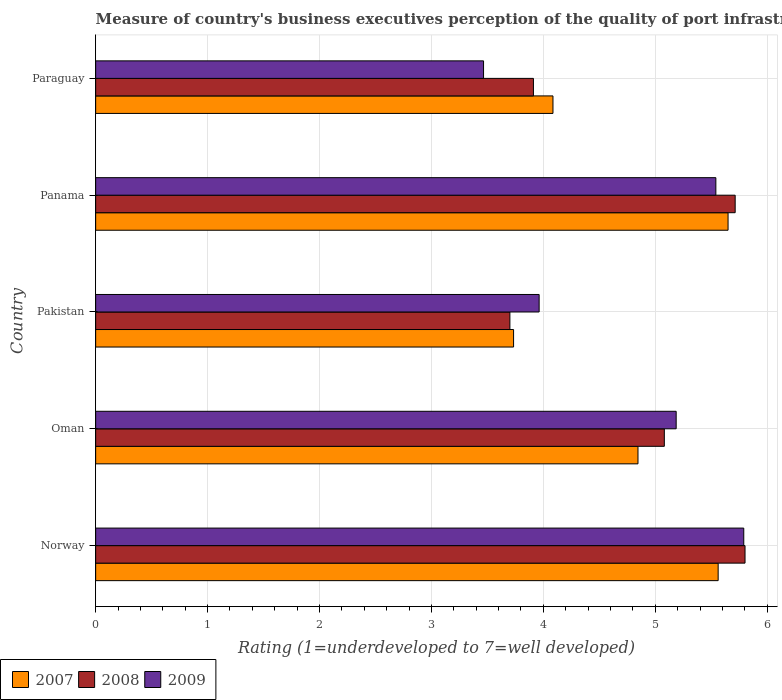How many different coloured bars are there?
Provide a short and direct response. 3. How many groups of bars are there?
Ensure brevity in your answer.  5. Are the number of bars on each tick of the Y-axis equal?
Give a very brief answer. Yes. How many bars are there on the 3rd tick from the top?
Your response must be concise. 3. What is the label of the 5th group of bars from the top?
Provide a short and direct response. Norway. In how many cases, is the number of bars for a given country not equal to the number of legend labels?
Your answer should be compact. 0. What is the ratings of the quality of port infrastructure in 2007 in Panama?
Provide a succinct answer. 5.65. Across all countries, what is the maximum ratings of the quality of port infrastructure in 2008?
Your answer should be very brief. 5.8. Across all countries, what is the minimum ratings of the quality of port infrastructure in 2009?
Offer a terse response. 3.47. In which country was the ratings of the quality of port infrastructure in 2007 maximum?
Provide a succinct answer. Panama. In which country was the ratings of the quality of port infrastructure in 2008 minimum?
Keep it short and to the point. Pakistan. What is the total ratings of the quality of port infrastructure in 2008 in the graph?
Your response must be concise. 24.21. What is the difference between the ratings of the quality of port infrastructure in 2008 in Pakistan and that in Panama?
Keep it short and to the point. -2.01. What is the difference between the ratings of the quality of port infrastructure in 2007 in Panama and the ratings of the quality of port infrastructure in 2009 in Paraguay?
Provide a short and direct response. 2.18. What is the average ratings of the quality of port infrastructure in 2009 per country?
Provide a short and direct response. 4.79. What is the difference between the ratings of the quality of port infrastructure in 2008 and ratings of the quality of port infrastructure in 2007 in Pakistan?
Give a very brief answer. -0.03. What is the ratio of the ratings of the quality of port infrastructure in 2008 in Oman to that in Panama?
Offer a terse response. 0.89. Is the ratings of the quality of port infrastructure in 2008 in Norway less than that in Oman?
Your response must be concise. No. What is the difference between the highest and the second highest ratings of the quality of port infrastructure in 2009?
Make the answer very short. 0.25. What is the difference between the highest and the lowest ratings of the quality of port infrastructure in 2009?
Provide a short and direct response. 2.32. How many bars are there?
Offer a terse response. 15. What is the difference between two consecutive major ticks on the X-axis?
Give a very brief answer. 1. Are the values on the major ticks of X-axis written in scientific E-notation?
Your response must be concise. No. Does the graph contain grids?
Offer a very short reply. Yes. How many legend labels are there?
Ensure brevity in your answer.  3. How are the legend labels stacked?
Provide a short and direct response. Horizontal. What is the title of the graph?
Your answer should be compact. Measure of country's business executives perception of the quality of port infrastructure. Does "1978" appear as one of the legend labels in the graph?
Ensure brevity in your answer.  No. What is the label or title of the X-axis?
Offer a terse response. Rating (1=underdeveloped to 7=well developed). What is the Rating (1=underdeveloped to 7=well developed) in 2007 in Norway?
Give a very brief answer. 5.56. What is the Rating (1=underdeveloped to 7=well developed) in 2008 in Norway?
Provide a succinct answer. 5.8. What is the Rating (1=underdeveloped to 7=well developed) in 2009 in Norway?
Give a very brief answer. 5.79. What is the Rating (1=underdeveloped to 7=well developed) of 2007 in Oman?
Ensure brevity in your answer.  4.85. What is the Rating (1=underdeveloped to 7=well developed) of 2008 in Oman?
Offer a terse response. 5.08. What is the Rating (1=underdeveloped to 7=well developed) in 2009 in Oman?
Ensure brevity in your answer.  5.19. What is the Rating (1=underdeveloped to 7=well developed) of 2007 in Pakistan?
Your response must be concise. 3.73. What is the Rating (1=underdeveloped to 7=well developed) in 2008 in Pakistan?
Offer a terse response. 3.7. What is the Rating (1=underdeveloped to 7=well developed) in 2009 in Pakistan?
Provide a succinct answer. 3.96. What is the Rating (1=underdeveloped to 7=well developed) in 2007 in Panama?
Offer a very short reply. 5.65. What is the Rating (1=underdeveloped to 7=well developed) in 2008 in Panama?
Make the answer very short. 5.71. What is the Rating (1=underdeveloped to 7=well developed) in 2009 in Panama?
Provide a succinct answer. 5.54. What is the Rating (1=underdeveloped to 7=well developed) of 2007 in Paraguay?
Provide a succinct answer. 4.09. What is the Rating (1=underdeveloped to 7=well developed) of 2008 in Paraguay?
Ensure brevity in your answer.  3.91. What is the Rating (1=underdeveloped to 7=well developed) of 2009 in Paraguay?
Offer a terse response. 3.47. Across all countries, what is the maximum Rating (1=underdeveloped to 7=well developed) in 2007?
Provide a succinct answer. 5.65. Across all countries, what is the maximum Rating (1=underdeveloped to 7=well developed) in 2008?
Make the answer very short. 5.8. Across all countries, what is the maximum Rating (1=underdeveloped to 7=well developed) in 2009?
Your answer should be compact. 5.79. Across all countries, what is the minimum Rating (1=underdeveloped to 7=well developed) of 2007?
Your answer should be very brief. 3.73. Across all countries, what is the minimum Rating (1=underdeveloped to 7=well developed) in 2008?
Make the answer very short. 3.7. Across all countries, what is the minimum Rating (1=underdeveloped to 7=well developed) in 2009?
Offer a very short reply. 3.47. What is the total Rating (1=underdeveloped to 7=well developed) of 2007 in the graph?
Give a very brief answer. 23.88. What is the total Rating (1=underdeveloped to 7=well developed) of 2008 in the graph?
Make the answer very short. 24.21. What is the total Rating (1=underdeveloped to 7=well developed) in 2009 in the graph?
Offer a terse response. 23.95. What is the difference between the Rating (1=underdeveloped to 7=well developed) of 2007 in Norway and that in Oman?
Keep it short and to the point. 0.72. What is the difference between the Rating (1=underdeveloped to 7=well developed) in 2008 in Norway and that in Oman?
Keep it short and to the point. 0.72. What is the difference between the Rating (1=underdeveloped to 7=well developed) of 2009 in Norway and that in Oman?
Keep it short and to the point. 0.6. What is the difference between the Rating (1=underdeveloped to 7=well developed) of 2007 in Norway and that in Pakistan?
Offer a very short reply. 1.83. What is the difference between the Rating (1=underdeveloped to 7=well developed) in 2008 in Norway and that in Pakistan?
Offer a very short reply. 2.1. What is the difference between the Rating (1=underdeveloped to 7=well developed) in 2009 in Norway and that in Pakistan?
Offer a terse response. 1.83. What is the difference between the Rating (1=underdeveloped to 7=well developed) in 2007 in Norway and that in Panama?
Ensure brevity in your answer.  -0.09. What is the difference between the Rating (1=underdeveloped to 7=well developed) in 2008 in Norway and that in Panama?
Your response must be concise. 0.09. What is the difference between the Rating (1=underdeveloped to 7=well developed) in 2009 in Norway and that in Panama?
Your response must be concise. 0.25. What is the difference between the Rating (1=underdeveloped to 7=well developed) of 2007 in Norway and that in Paraguay?
Your response must be concise. 1.48. What is the difference between the Rating (1=underdeveloped to 7=well developed) in 2008 in Norway and that in Paraguay?
Your response must be concise. 1.89. What is the difference between the Rating (1=underdeveloped to 7=well developed) in 2009 in Norway and that in Paraguay?
Offer a very short reply. 2.32. What is the difference between the Rating (1=underdeveloped to 7=well developed) in 2007 in Oman and that in Pakistan?
Your response must be concise. 1.11. What is the difference between the Rating (1=underdeveloped to 7=well developed) in 2008 in Oman and that in Pakistan?
Offer a terse response. 1.38. What is the difference between the Rating (1=underdeveloped to 7=well developed) of 2009 in Oman and that in Pakistan?
Your answer should be very brief. 1.22. What is the difference between the Rating (1=underdeveloped to 7=well developed) in 2007 in Oman and that in Panama?
Your response must be concise. -0.8. What is the difference between the Rating (1=underdeveloped to 7=well developed) in 2008 in Oman and that in Panama?
Provide a short and direct response. -0.63. What is the difference between the Rating (1=underdeveloped to 7=well developed) of 2009 in Oman and that in Panama?
Give a very brief answer. -0.35. What is the difference between the Rating (1=underdeveloped to 7=well developed) of 2007 in Oman and that in Paraguay?
Provide a succinct answer. 0.76. What is the difference between the Rating (1=underdeveloped to 7=well developed) in 2008 in Oman and that in Paraguay?
Ensure brevity in your answer.  1.17. What is the difference between the Rating (1=underdeveloped to 7=well developed) in 2009 in Oman and that in Paraguay?
Your answer should be compact. 1.72. What is the difference between the Rating (1=underdeveloped to 7=well developed) in 2007 in Pakistan and that in Panama?
Your answer should be very brief. -1.92. What is the difference between the Rating (1=underdeveloped to 7=well developed) of 2008 in Pakistan and that in Panama?
Provide a succinct answer. -2.01. What is the difference between the Rating (1=underdeveloped to 7=well developed) in 2009 in Pakistan and that in Panama?
Provide a succinct answer. -1.58. What is the difference between the Rating (1=underdeveloped to 7=well developed) in 2007 in Pakistan and that in Paraguay?
Your answer should be compact. -0.35. What is the difference between the Rating (1=underdeveloped to 7=well developed) in 2008 in Pakistan and that in Paraguay?
Provide a succinct answer. -0.21. What is the difference between the Rating (1=underdeveloped to 7=well developed) of 2009 in Pakistan and that in Paraguay?
Ensure brevity in your answer.  0.5. What is the difference between the Rating (1=underdeveloped to 7=well developed) of 2007 in Panama and that in Paraguay?
Ensure brevity in your answer.  1.56. What is the difference between the Rating (1=underdeveloped to 7=well developed) of 2008 in Panama and that in Paraguay?
Your answer should be compact. 1.8. What is the difference between the Rating (1=underdeveloped to 7=well developed) in 2009 in Panama and that in Paraguay?
Offer a very short reply. 2.08. What is the difference between the Rating (1=underdeveloped to 7=well developed) of 2007 in Norway and the Rating (1=underdeveloped to 7=well developed) of 2008 in Oman?
Provide a short and direct response. 0.48. What is the difference between the Rating (1=underdeveloped to 7=well developed) of 2007 in Norway and the Rating (1=underdeveloped to 7=well developed) of 2009 in Oman?
Provide a short and direct response. 0.38. What is the difference between the Rating (1=underdeveloped to 7=well developed) in 2008 in Norway and the Rating (1=underdeveloped to 7=well developed) in 2009 in Oman?
Offer a terse response. 0.62. What is the difference between the Rating (1=underdeveloped to 7=well developed) of 2007 in Norway and the Rating (1=underdeveloped to 7=well developed) of 2008 in Pakistan?
Your answer should be compact. 1.86. What is the difference between the Rating (1=underdeveloped to 7=well developed) of 2007 in Norway and the Rating (1=underdeveloped to 7=well developed) of 2009 in Pakistan?
Give a very brief answer. 1.6. What is the difference between the Rating (1=underdeveloped to 7=well developed) of 2008 in Norway and the Rating (1=underdeveloped to 7=well developed) of 2009 in Pakistan?
Offer a very short reply. 1.84. What is the difference between the Rating (1=underdeveloped to 7=well developed) in 2007 in Norway and the Rating (1=underdeveloped to 7=well developed) in 2008 in Panama?
Offer a terse response. -0.15. What is the difference between the Rating (1=underdeveloped to 7=well developed) of 2007 in Norway and the Rating (1=underdeveloped to 7=well developed) of 2009 in Panama?
Keep it short and to the point. 0.02. What is the difference between the Rating (1=underdeveloped to 7=well developed) of 2008 in Norway and the Rating (1=underdeveloped to 7=well developed) of 2009 in Panama?
Offer a terse response. 0.26. What is the difference between the Rating (1=underdeveloped to 7=well developed) in 2007 in Norway and the Rating (1=underdeveloped to 7=well developed) in 2008 in Paraguay?
Provide a succinct answer. 1.65. What is the difference between the Rating (1=underdeveloped to 7=well developed) of 2007 in Norway and the Rating (1=underdeveloped to 7=well developed) of 2009 in Paraguay?
Offer a very short reply. 2.1. What is the difference between the Rating (1=underdeveloped to 7=well developed) of 2008 in Norway and the Rating (1=underdeveloped to 7=well developed) of 2009 in Paraguay?
Provide a short and direct response. 2.34. What is the difference between the Rating (1=underdeveloped to 7=well developed) in 2007 in Oman and the Rating (1=underdeveloped to 7=well developed) in 2008 in Pakistan?
Provide a short and direct response. 1.14. What is the difference between the Rating (1=underdeveloped to 7=well developed) of 2007 in Oman and the Rating (1=underdeveloped to 7=well developed) of 2009 in Pakistan?
Your answer should be very brief. 0.88. What is the difference between the Rating (1=underdeveloped to 7=well developed) of 2008 in Oman and the Rating (1=underdeveloped to 7=well developed) of 2009 in Pakistan?
Ensure brevity in your answer.  1.12. What is the difference between the Rating (1=underdeveloped to 7=well developed) of 2007 in Oman and the Rating (1=underdeveloped to 7=well developed) of 2008 in Panama?
Offer a very short reply. -0.87. What is the difference between the Rating (1=underdeveloped to 7=well developed) of 2007 in Oman and the Rating (1=underdeveloped to 7=well developed) of 2009 in Panama?
Your answer should be very brief. -0.7. What is the difference between the Rating (1=underdeveloped to 7=well developed) in 2008 in Oman and the Rating (1=underdeveloped to 7=well developed) in 2009 in Panama?
Your answer should be very brief. -0.46. What is the difference between the Rating (1=underdeveloped to 7=well developed) of 2007 in Oman and the Rating (1=underdeveloped to 7=well developed) of 2008 in Paraguay?
Keep it short and to the point. 0.93. What is the difference between the Rating (1=underdeveloped to 7=well developed) of 2007 in Oman and the Rating (1=underdeveloped to 7=well developed) of 2009 in Paraguay?
Your answer should be very brief. 1.38. What is the difference between the Rating (1=underdeveloped to 7=well developed) in 2008 in Oman and the Rating (1=underdeveloped to 7=well developed) in 2009 in Paraguay?
Your answer should be compact. 1.62. What is the difference between the Rating (1=underdeveloped to 7=well developed) in 2007 in Pakistan and the Rating (1=underdeveloped to 7=well developed) in 2008 in Panama?
Ensure brevity in your answer.  -1.98. What is the difference between the Rating (1=underdeveloped to 7=well developed) in 2007 in Pakistan and the Rating (1=underdeveloped to 7=well developed) in 2009 in Panama?
Make the answer very short. -1.81. What is the difference between the Rating (1=underdeveloped to 7=well developed) in 2008 in Pakistan and the Rating (1=underdeveloped to 7=well developed) in 2009 in Panama?
Offer a terse response. -1.84. What is the difference between the Rating (1=underdeveloped to 7=well developed) of 2007 in Pakistan and the Rating (1=underdeveloped to 7=well developed) of 2008 in Paraguay?
Your answer should be compact. -0.18. What is the difference between the Rating (1=underdeveloped to 7=well developed) of 2007 in Pakistan and the Rating (1=underdeveloped to 7=well developed) of 2009 in Paraguay?
Make the answer very short. 0.27. What is the difference between the Rating (1=underdeveloped to 7=well developed) of 2008 in Pakistan and the Rating (1=underdeveloped to 7=well developed) of 2009 in Paraguay?
Your answer should be very brief. 0.24. What is the difference between the Rating (1=underdeveloped to 7=well developed) of 2007 in Panama and the Rating (1=underdeveloped to 7=well developed) of 2008 in Paraguay?
Provide a short and direct response. 1.74. What is the difference between the Rating (1=underdeveloped to 7=well developed) in 2007 in Panama and the Rating (1=underdeveloped to 7=well developed) in 2009 in Paraguay?
Provide a short and direct response. 2.18. What is the difference between the Rating (1=underdeveloped to 7=well developed) of 2008 in Panama and the Rating (1=underdeveloped to 7=well developed) of 2009 in Paraguay?
Your answer should be very brief. 2.25. What is the average Rating (1=underdeveloped to 7=well developed) in 2007 per country?
Provide a succinct answer. 4.78. What is the average Rating (1=underdeveloped to 7=well developed) in 2008 per country?
Your answer should be compact. 4.84. What is the average Rating (1=underdeveloped to 7=well developed) of 2009 per country?
Your response must be concise. 4.79. What is the difference between the Rating (1=underdeveloped to 7=well developed) of 2007 and Rating (1=underdeveloped to 7=well developed) of 2008 in Norway?
Your answer should be compact. -0.24. What is the difference between the Rating (1=underdeveloped to 7=well developed) in 2007 and Rating (1=underdeveloped to 7=well developed) in 2009 in Norway?
Offer a terse response. -0.23. What is the difference between the Rating (1=underdeveloped to 7=well developed) of 2008 and Rating (1=underdeveloped to 7=well developed) of 2009 in Norway?
Your answer should be very brief. 0.01. What is the difference between the Rating (1=underdeveloped to 7=well developed) of 2007 and Rating (1=underdeveloped to 7=well developed) of 2008 in Oman?
Provide a short and direct response. -0.24. What is the difference between the Rating (1=underdeveloped to 7=well developed) in 2007 and Rating (1=underdeveloped to 7=well developed) in 2009 in Oman?
Give a very brief answer. -0.34. What is the difference between the Rating (1=underdeveloped to 7=well developed) of 2008 and Rating (1=underdeveloped to 7=well developed) of 2009 in Oman?
Provide a succinct answer. -0.11. What is the difference between the Rating (1=underdeveloped to 7=well developed) of 2007 and Rating (1=underdeveloped to 7=well developed) of 2008 in Pakistan?
Make the answer very short. 0.03. What is the difference between the Rating (1=underdeveloped to 7=well developed) in 2007 and Rating (1=underdeveloped to 7=well developed) in 2009 in Pakistan?
Your answer should be compact. -0.23. What is the difference between the Rating (1=underdeveloped to 7=well developed) in 2008 and Rating (1=underdeveloped to 7=well developed) in 2009 in Pakistan?
Give a very brief answer. -0.26. What is the difference between the Rating (1=underdeveloped to 7=well developed) in 2007 and Rating (1=underdeveloped to 7=well developed) in 2008 in Panama?
Your answer should be compact. -0.06. What is the difference between the Rating (1=underdeveloped to 7=well developed) of 2007 and Rating (1=underdeveloped to 7=well developed) of 2009 in Panama?
Make the answer very short. 0.11. What is the difference between the Rating (1=underdeveloped to 7=well developed) of 2008 and Rating (1=underdeveloped to 7=well developed) of 2009 in Panama?
Your answer should be compact. 0.17. What is the difference between the Rating (1=underdeveloped to 7=well developed) in 2007 and Rating (1=underdeveloped to 7=well developed) in 2008 in Paraguay?
Provide a succinct answer. 0.17. What is the difference between the Rating (1=underdeveloped to 7=well developed) in 2007 and Rating (1=underdeveloped to 7=well developed) in 2009 in Paraguay?
Give a very brief answer. 0.62. What is the difference between the Rating (1=underdeveloped to 7=well developed) of 2008 and Rating (1=underdeveloped to 7=well developed) of 2009 in Paraguay?
Provide a short and direct response. 0.45. What is the ratio of the Rating (1=underdeveloped to 7=well developed) in 2007 in Norway to that in Oman?
Give a very brief answer. 1.15. What is the ratio of the Rating (1=underdeveloped to 7=well developed) of 2008 in Norway to that in Oman?
Your response must be concise. 1.14. What is the ratio of the Rating (1=underdeveloped to 7=well developed) of 2009 in Norway to that in Oman?
Your response must be concise. 1.12. What is the ratio of the Rating (1=underdeveloped to 7=well developed) in 2007 in Norway to that in Pakistan?
Give a very brief answer. 1.49. What is the ratio of the Rating (1=underdeveloped to 7=well developed) in 2008 in Norway to that in Pakistan?
Ensure brevity in your answer.  1.57. What is the ratio of the Rating (1=underdeveloped to 7=well developed) in 2009 in Norway to that in Pakistan?
Your response must be concise. 1.46. What is the ratio of the Rating (1=underdeveloped to 7=well developed) of 2007 in Norway to that in Panama?
Your response must be concise. 0.98. What is the ratio of the Rating (1=underdeveloped to 7=well developed) in 2008 in Norway to that in Panama?
Make the answer very short. 1.02. What is the ratio of the Rating (1=underdeveloped to 7=well developed) of 2009 in Norway to that in Panama?
Offer a very short reply. 1.04. What is the ratio of the Rating (1=underdeveloped to 7=well developed) in 2007 in Norway to that in Paraguay?
Give a very brief answer. 1.36. What is the ratio of the Rating (1=underdeveloped to 7=well developed) of 2008 in Norway to that in Paraguay?
Your response must be concise. 1.48. What is the ratio of the Rating (1=underdeveloped to 7=well developed) of 2009 in Norway to that in Paraguay?
Your answer should be very brief. 1.67. What is the ratio of the Rating (1=underdeveloped to 7=well developed) in 2007 in Oman to that in Pakistan?
Your response must be concise. 1.3. What is the ratio of the Rating (1=underdeveloped to 7=well developed) of 2008 in Oman to that in Pakistan?
Offer a terse response. 1.37. What is the ratio of the Rating (1=underdeveloped to 7=well developed) in 2009 in Oman to that in Pakistan?
Keep it short and to the point. 1.31. What is the ratio of the Rating (1=underdeveloped to 7=well developed) in 2007 in Oman to that in Panama?
Offer a terse response. 0.86. What is the ratio of the Rating (1=underdeveloped to 7=well developed) in 2008 in Oman to that in Panama?
Ensure brevity in your answer.  0.89. What is the ratio of the Rating (1=underdeveloped to 7=well developed) of 2009 in Oman to that in Panama?
Provide a short and direct response. 0.94. What is the ratio of the Rating (1=underdeveloped to 7=well developed) of 2007 in Oman to that in Paraguay?
Keep it short and to the point. 1.19. What is the ratio of the Rating (1=underdeveloped to 7=well developed) of 2008 in Oman to that in Paraguay?
Offer a very short reply. 1.3. What is the ratio of the Rating (1=underdeveloped to 7=well developed) in 2009 in Oman to that in Paraguay?
Offer a terse response. 1.5. What is the ratio of the Rating (1=underdeveloped to 7=well developed) in 2007 in Pakistan to that in Panama?
Your answer should be compact. 0.66. What is the ratio of the Rating (1=underdeveloped to 7=well developed) in 2008 in Pakistan to that in Panama?
Offer a very short reply. 0.65. What is the ratio of the Rating (1=underdeveloped to 7=well developed) in 2009 in Pakistan to that in Panama?
Make the answer very short. 0.72. What is the ratio of the Rating (1=underdeveloped to 7=well developed) of 2007 in Pakistan to that in Paraguay?
Give a very brief answer. 0.91. What is the ratio of the Rating (1=underdeveloped to 7=well developed) of 2008 in Pakistan to that in Paraguay?
Offer a very short reply. 0.95. What is the ratio of the Rating (1=underdeveloped to 7=well developed) in 2009 in Pakistan to that in Paraguay?
Your answer should be compact. 1.14. What is the ratio of the Rating (1=underdeveloped to 7=well developed) of 2007 in Panama to that in Paraguay?
Give a very brief answer. 1.38. What is the ratio of the Rating (1=underdeveloped to 7=well developed) in 2008 in Panama to that in Paraguay?
Make the answer very short. 1.46. What is the ratio of the Rating (1=underdeveloped to 7=well developed) in 2009 in Panama to that in Paraguay?
Provide a succinct answer. 1.6. What is the difference between the highest and the second highest Rating (1=underdeveloped to 7=well developed) in 2007?
Provide a succinct answer. 0.09. What is the difference between the highest and the second highest Rating (1=underdeveloped to 7=well developed) in 2008?
Your response must be concise. 0.09. What is the difference between the highest and the second highest Rating (1=underdeveloped to 7=well developed) in 2009?
Give a very brief answer. 0.25. What is the difference between the highest and the lowest Rating (1=underdeveloped to 7=well developed) of 2007?
Your response must be concise. 1.92. What is the difference between the highest and the lowest Rating (1=underdeveloped to 7=well developed) in 2008?
Provide a succinct answer. 2.1. What is the difference between the highest and the lowest Rating (1=underdeveloped to 7=well developed) of 2009?
Make the answer very short. 2.32. 